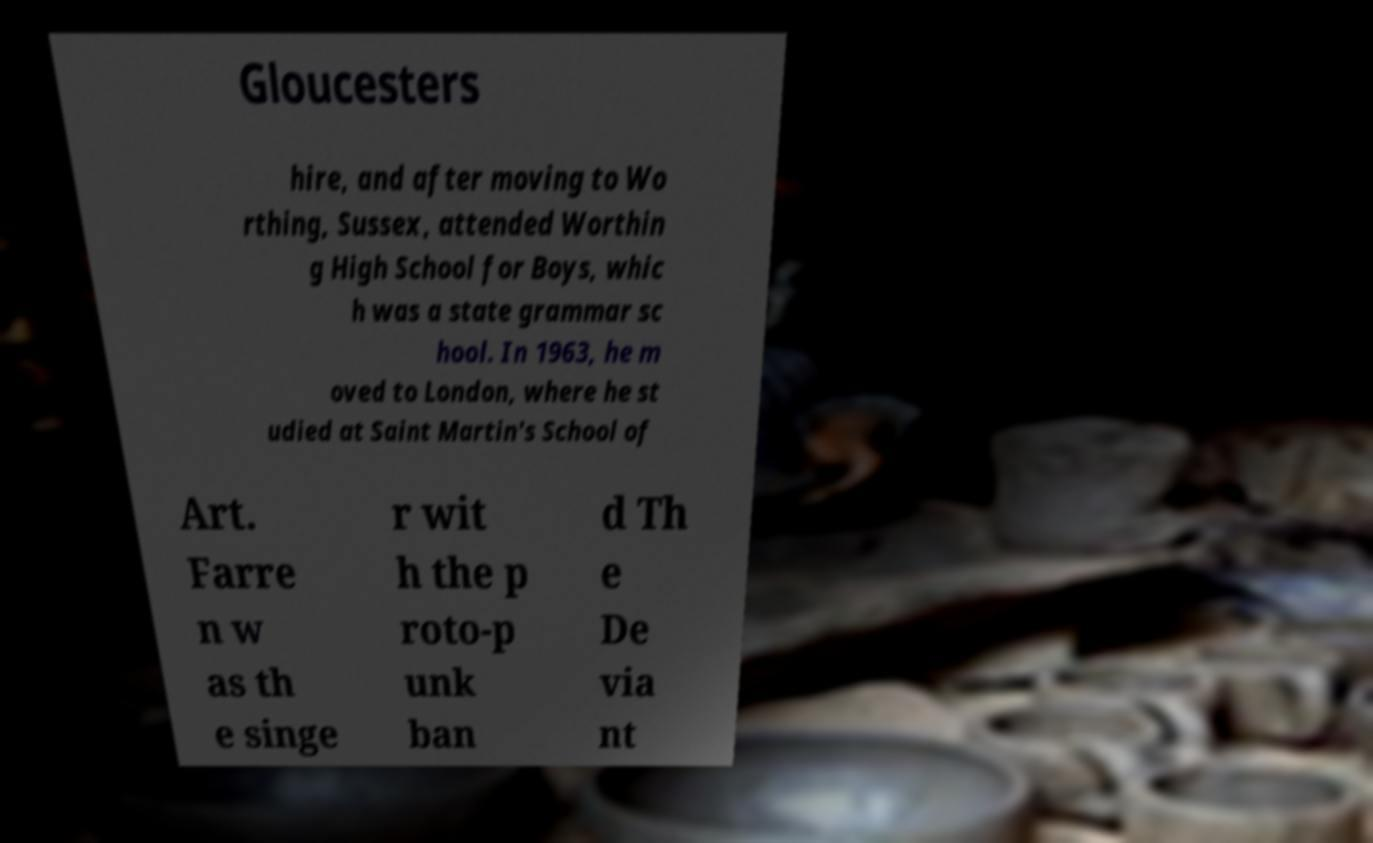Please identify and transcribe the text found in this image. Gloucesters hire, and after moving to Wo rthing, Sussex, attended Worthin g High School for Boys, whic h was a state grammar sc hool. In 1963, he m oved to London, where he st udied at Saint Martin's School of Art. Farre n w as th e singe r wit h the p roto-p unk ban d Th e De via nt 